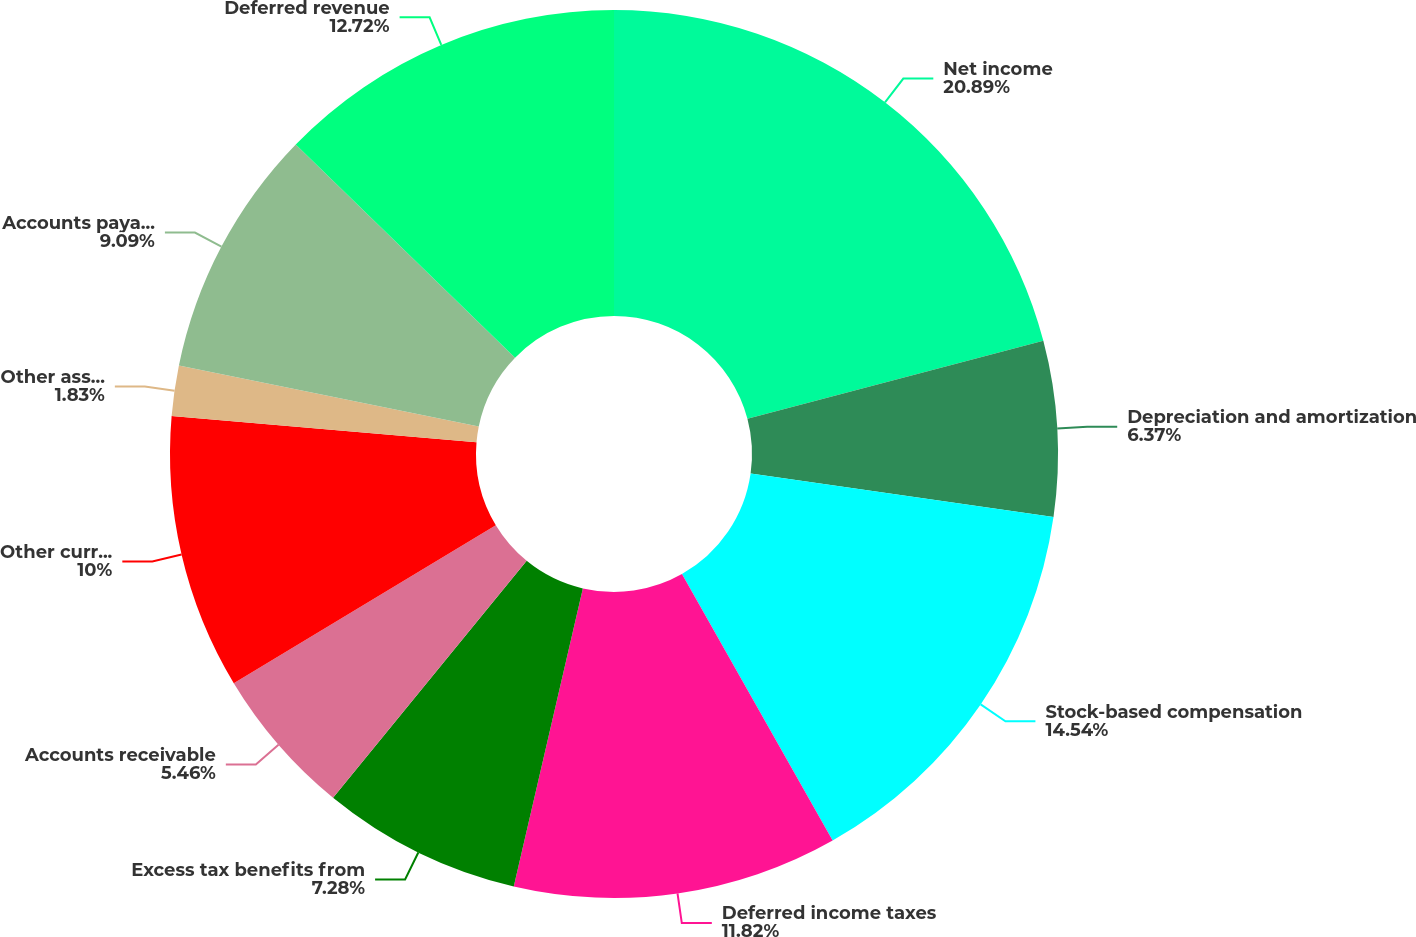Convert chart. <chart><loc_0><loc_0><loc_500><loc_500><pie_chart><fcel>Net income<fcel>Depreciation and amortization<fcel>Stock-based compensation<fcel>Deferred income taxes<fcel>Excess tax benefits from<fcel>Accounts receivable<fcel>Other current assets<fcel>Other assets and prepaid<fcel>Accounts payable and accrued<fcel>Deferred revenue<nl><fcel>20.9%<fcel>6.37%<fcel>14.54%<fcel>11.82%<fcel>7.28%<fcel>5.46%<fcel>10.0%<fcel>1.83%<fcel>9.09%<fcel>12.72%<nl></chart> 